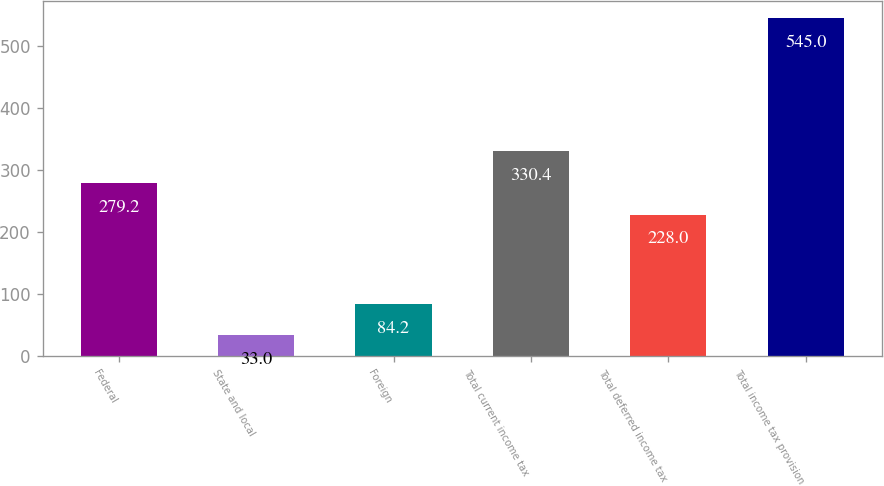<chart> <loc_0><loc_0><loc_500><loc_500><bar_chart><fcel>Federal<fcel>State and local<fcel>Foreign<fcel>Total current income tax<fcel>Total deferred income tax<fcel>Total income tax provision<nl><fcel>279.2<fcel>33<fcel>84.2<fcel>330.4<fcel>228<fcel>545<nl></chart> 